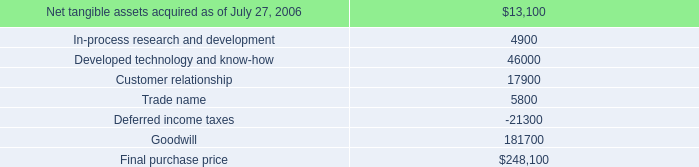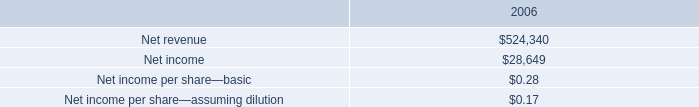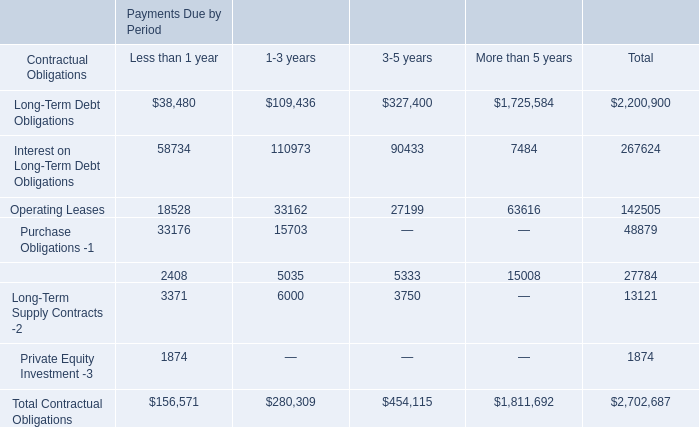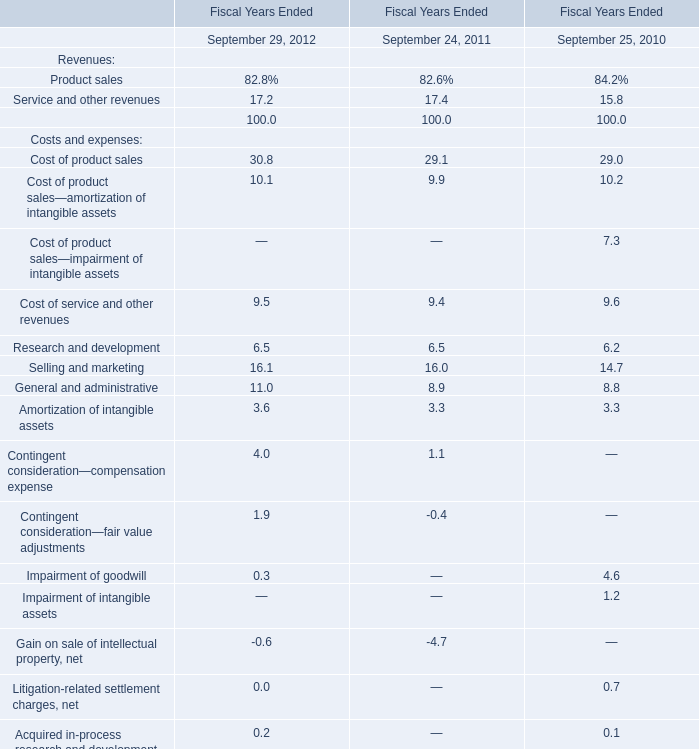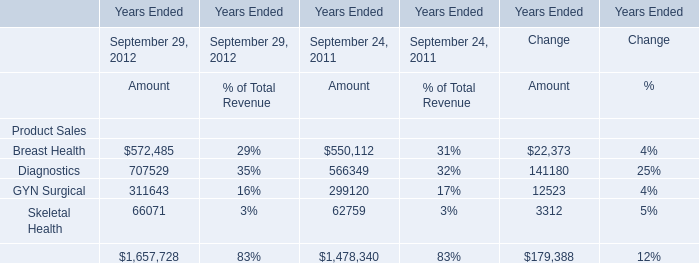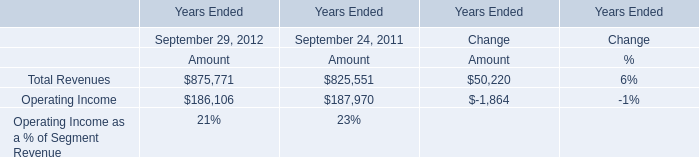What's the average of Breast Health of Years Ended Change Amount, and Operating Income of Years Ended September 24, 2011 Amount ? 
Computations: ((22373.0 + 187970.0) / 2)
Answer: 105171.5. 